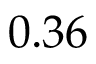<formula> <loc_0><loc_0><loc_500><loc_500>0 . 3 6</formula> 